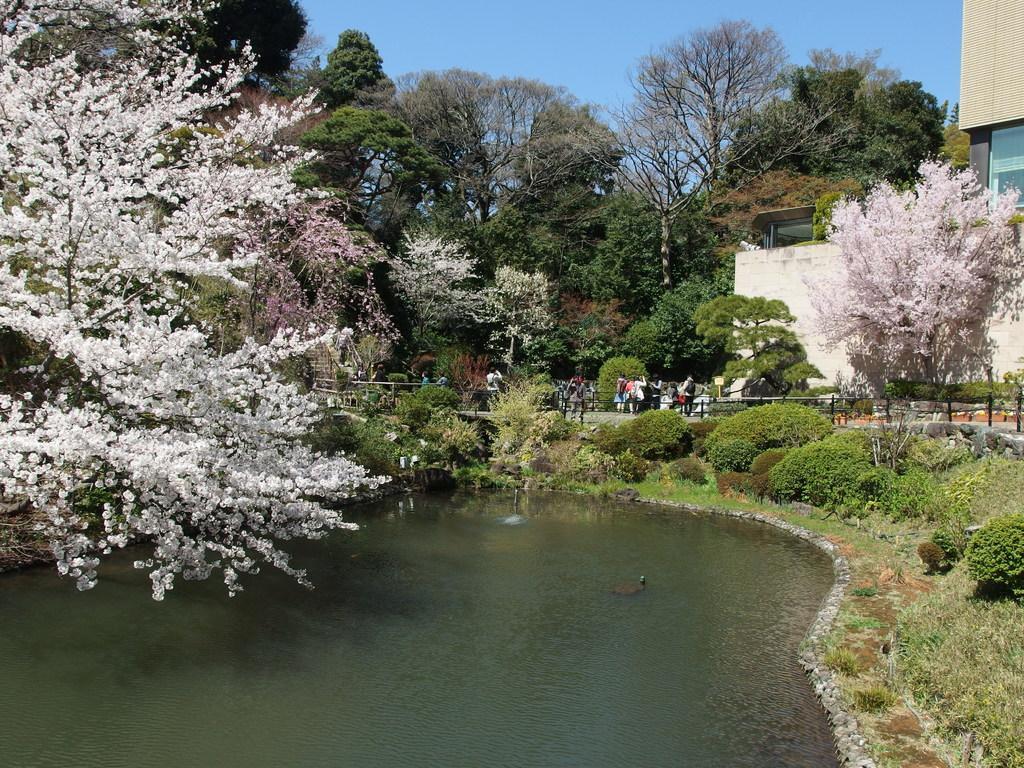Describe this image in one or two sentences. In this image there is a lake beside that there are trees, plants, building and also there is a road where so many people are standing. 